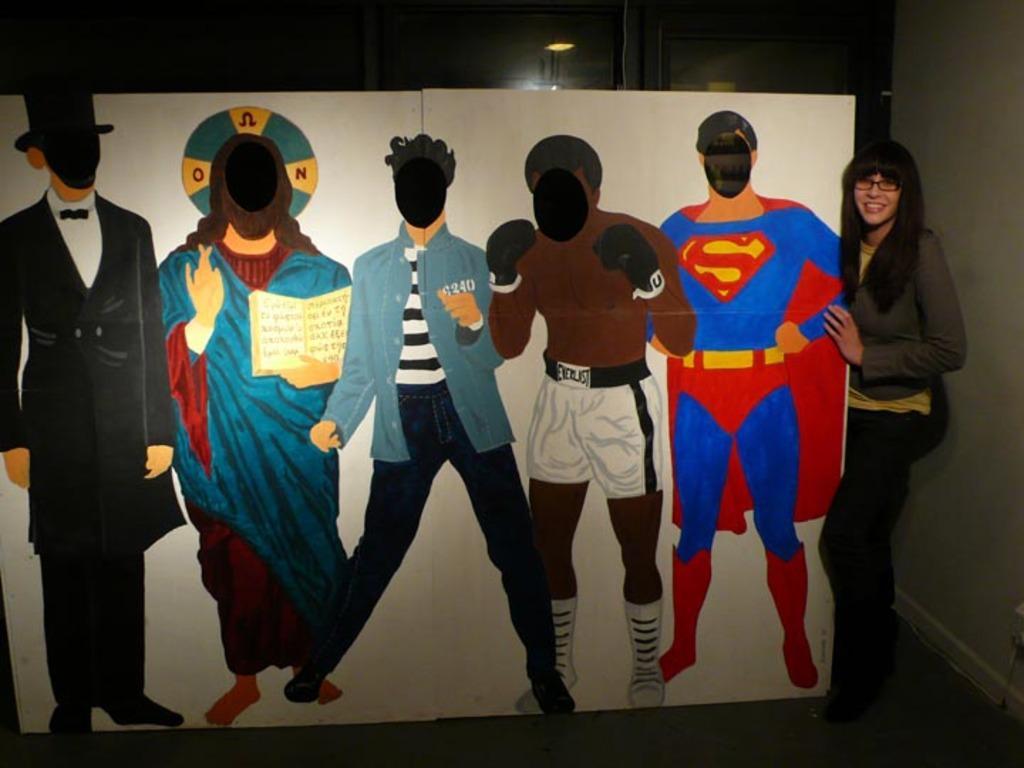In one or two sentences, can you explain what this image depicts? In this picture we can see one board, on which we can see some persons paintings, side we can see a woman standing and holding. 